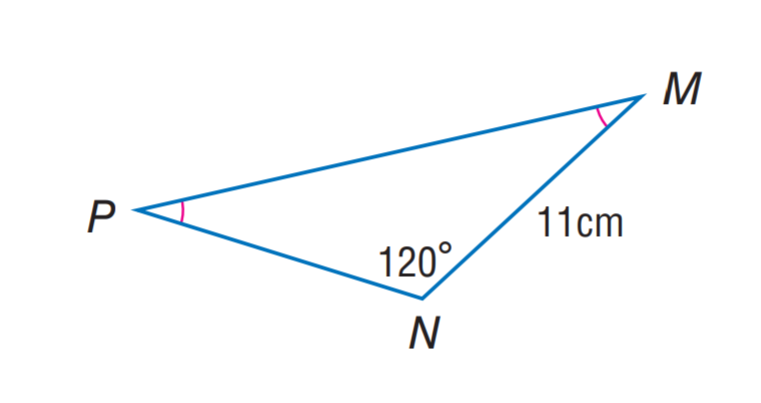Question: Find m \angle M.
Choices:
A. 20
B. 30
C. 60
D. 120
Answer with the letter. Answer: B 